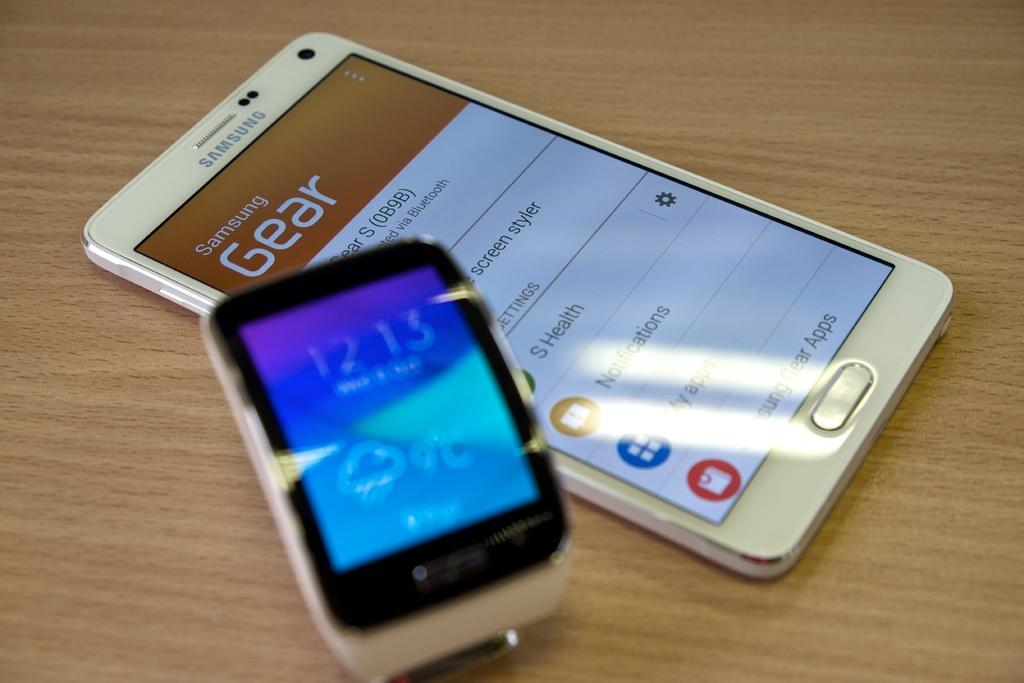<image>
Give a short and clear explanation of the subsequent image. A smart watch showing the time as 12:13 laying on top of a Samsung cell phone. 